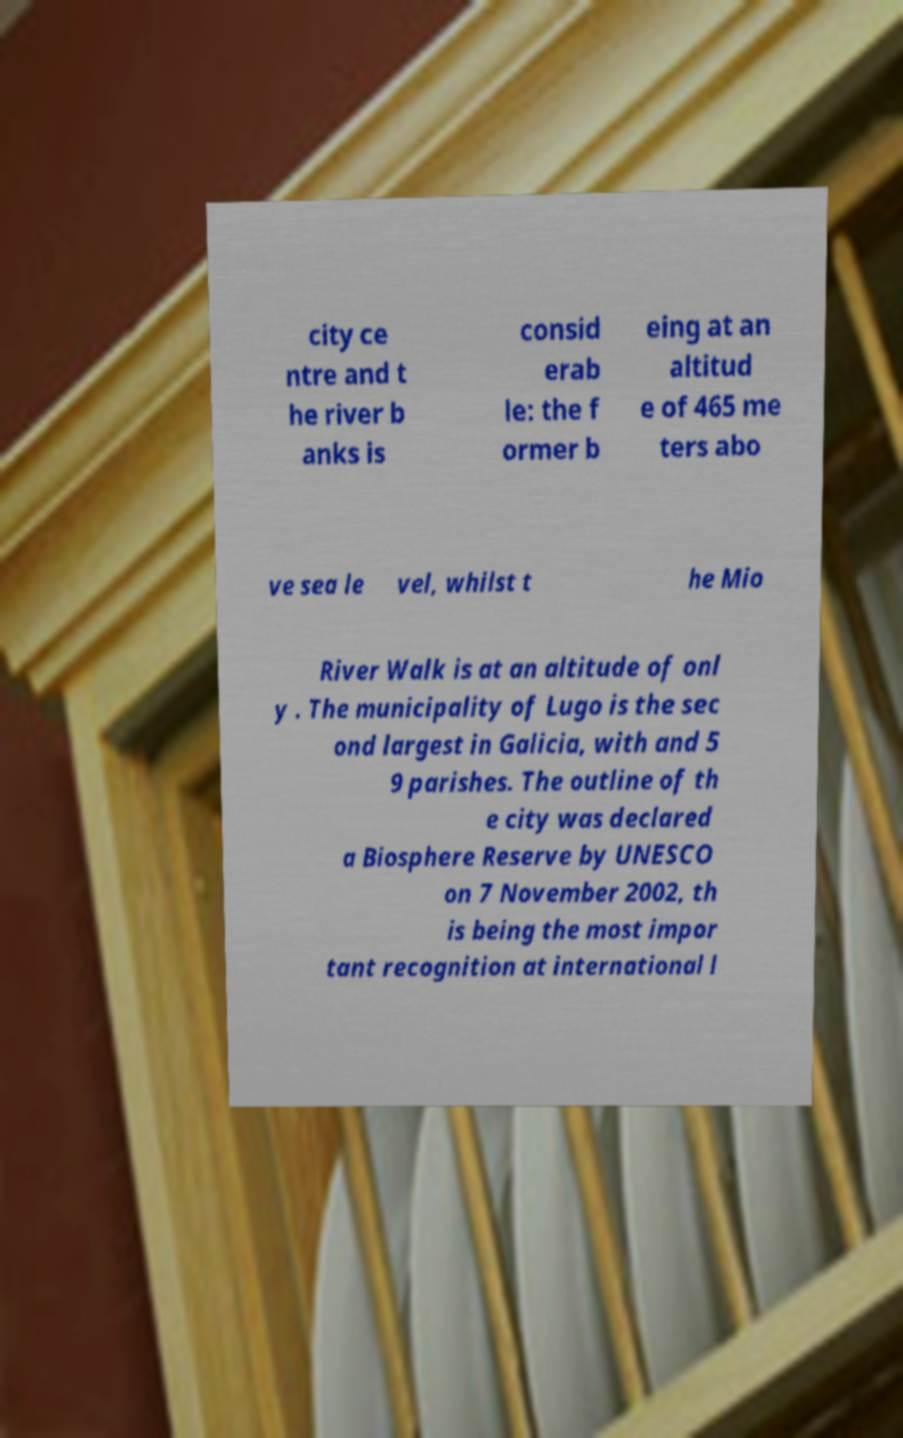Can you accurately transcribe the text from the provided image for me? city ce ntre and t he river b anks is consid erab le: the f ormer b eing at an altitud e of 465 me ters abo ve sea le vel, whilst t he Mio River Walk is at an altitude of onl y . The municipality of Lugo is the sec ond largest in Galicia, with and 5 9 parishes. The outline of th e city was declared a Biosphere Reserve by UNESCO on 7 November 2002, th is being the most impor tant recognition at international l 